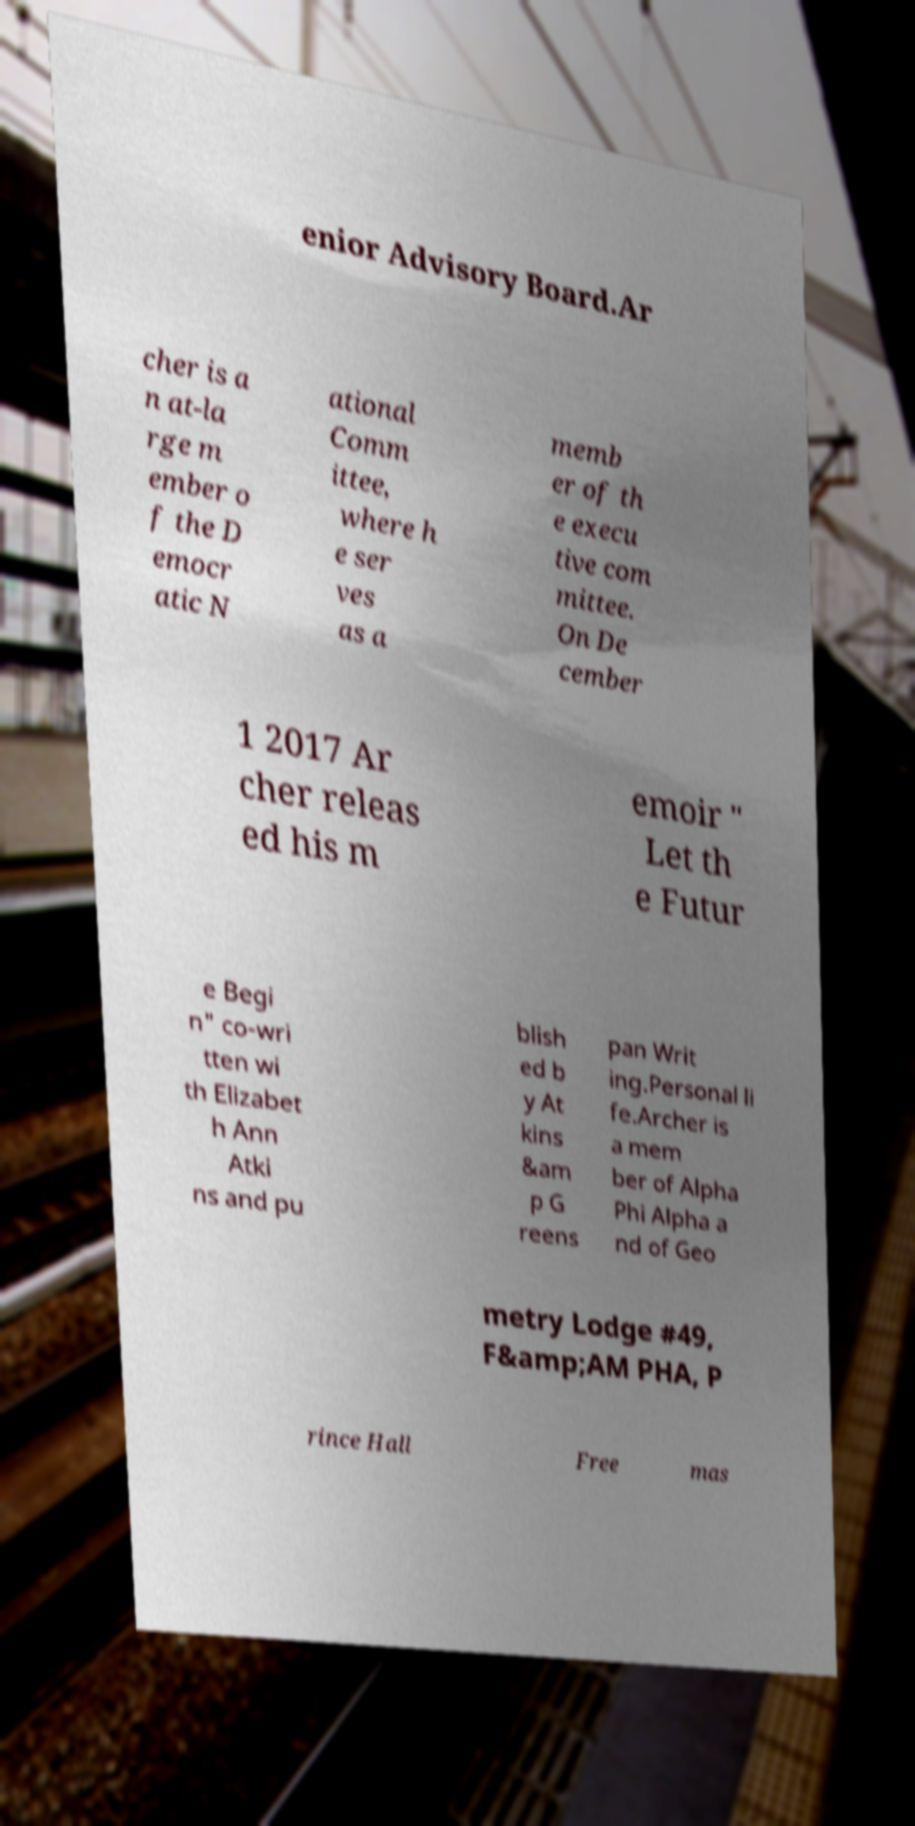I need the written content from this picture converted into text. Can you do that? enior Advisory Board.Ar cher is a n at-la rge m ember o f the D emocr atic N ational Comm ittee, where h e ser ves as a memb er of th e execu tive com mittee. On De cember 1 2017 Ar cher releas ed his m emoir " Let th e Futur e Begi n" co-wri tten wi th Elizabet h Ann Atki ns and pu blish ed b y At kins &am p G reens pan Writ ing.Personal li fe.Archer is a mem ber of Alpha Phi Alpha a nd of Geo metry Lodge #49, F&amp;AM PHA, P rince Hall Free mas 